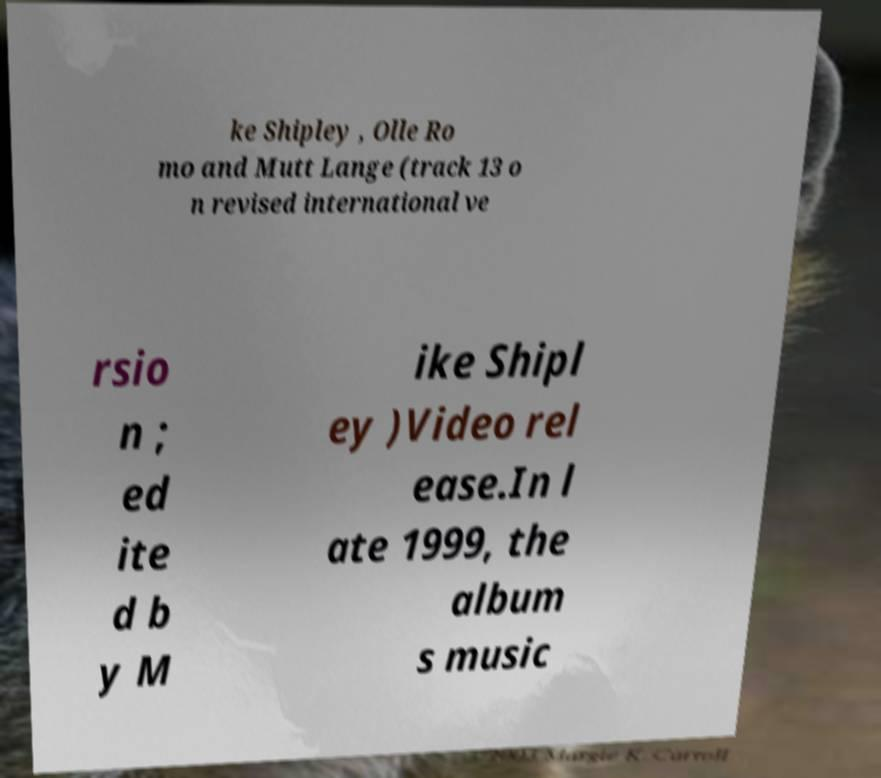Can you read and provide the text displayed in the image?This photo seems to have some interesting text. Can you extract and type it out for me? ke Shipley , Olle Ro mo and Mutt Lange (track 13 o n revised international ve rsio n ; ed ite d b y M ike Shipl ey )Video rel ease.In l ate 1999, the album s music 